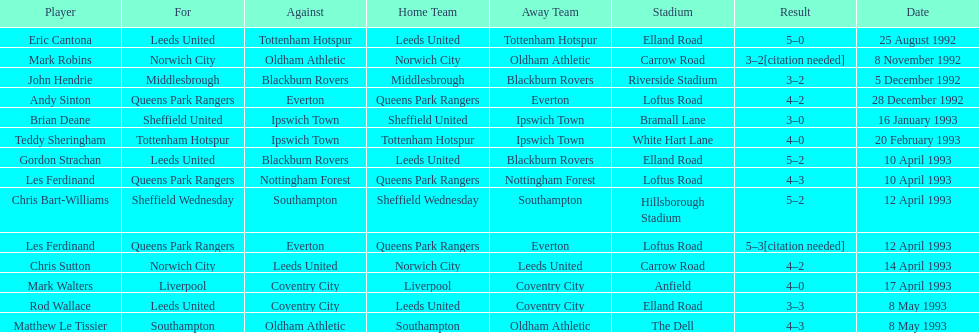Which team did liverpool play against? Coventry City. 